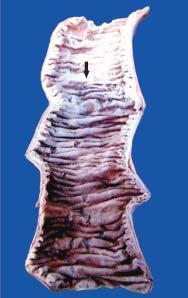what is soft, swollen and dark?
Answer the question using a single word or phrase. The affected part dark 